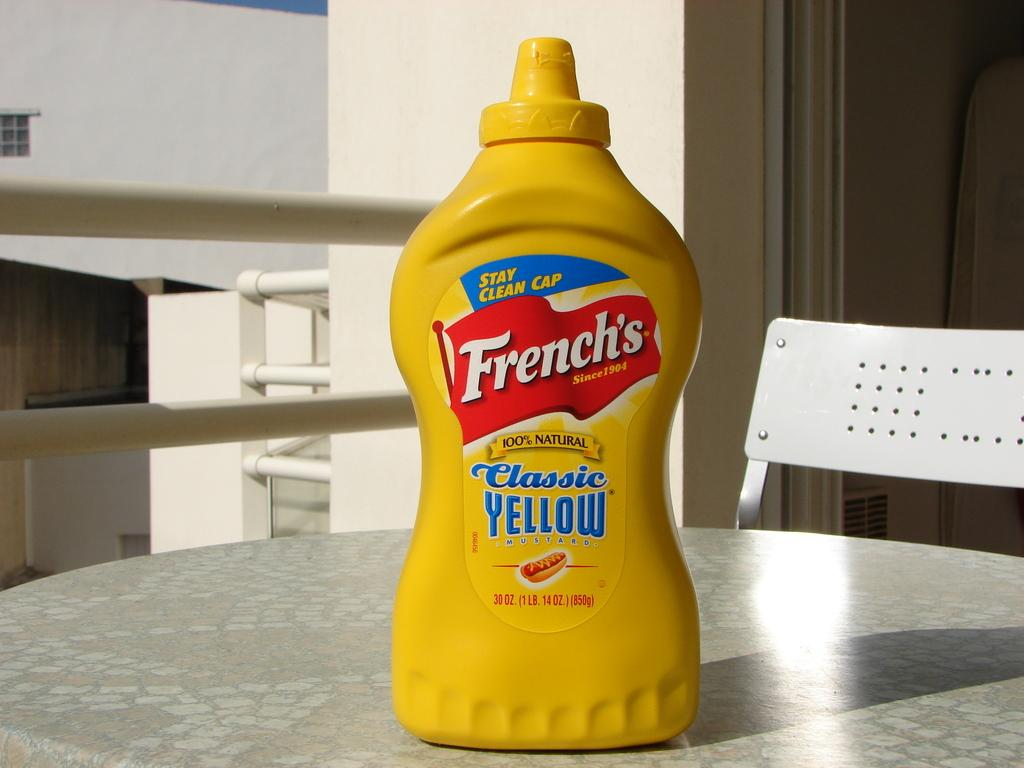What object is placed on the table in the image? There is a bottle on the table in the image. What type of furniture is visible at the back of the image? There is a chair at the back of the image. What is the background of the image? There is a wall at the back of the image. What type of mist can be seen surrounding the chair in the image? There is no mist present in the image; it features a bottle on a table and a chair and wall at the back. How many wrists are visible in the image? There are no wrists visible in the image. 